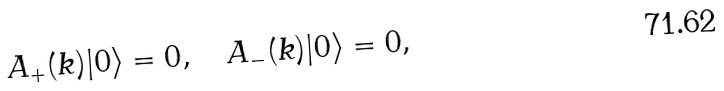<formula> <loc_0><loc_0><loc_500><loc_500>A _ { + } ( { k } ) | 0 \rangle = 0 , \quad A _ { - } ( { k } ) | 0 \rangle = 0 ,</formula> 